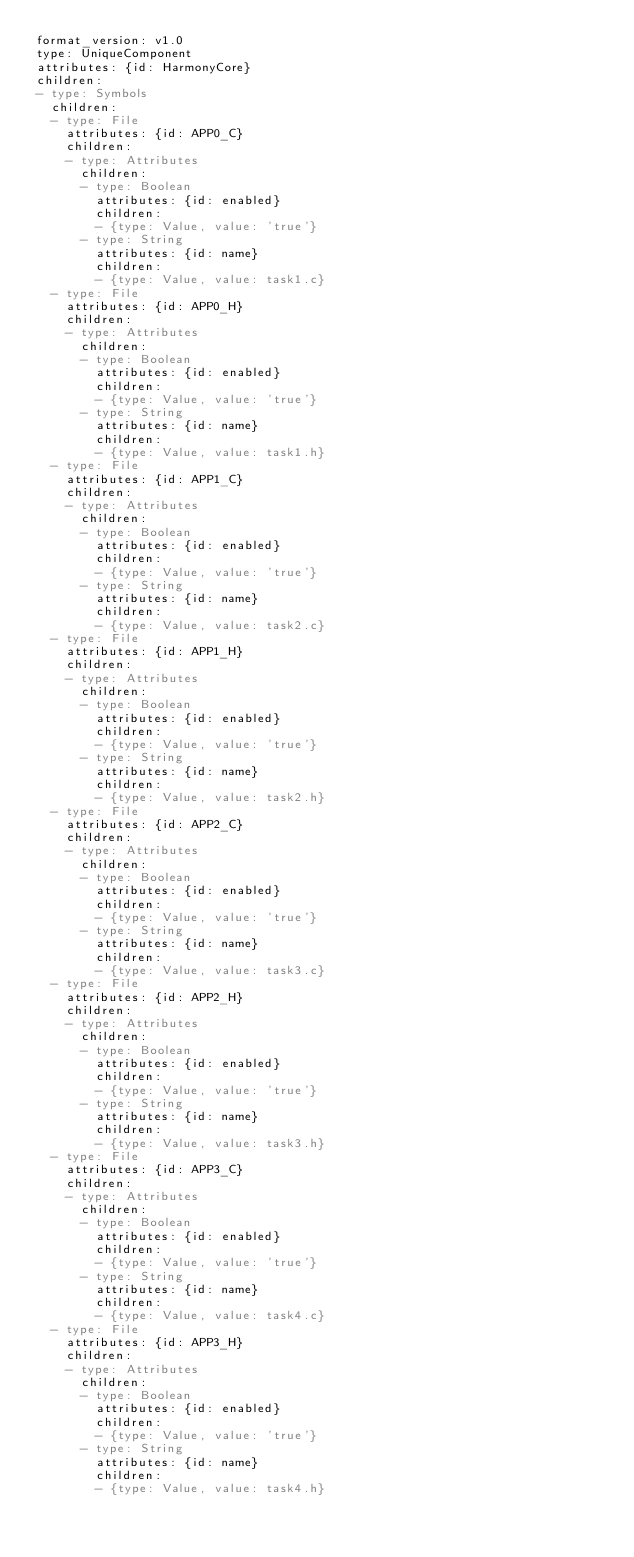<code> <loc_0><loc_0><loc_500><loc_500><_YAML_>format_version: v1.0
type: UniqueComponent
attributes: {id: HarmonyCore}
children:
- type: Symbols
  children:
  - type: File
    attributes: {id: APP0_C}
    children:
    - type: Attributes
      children:
      - type: Boolean
        attributes: {id: enabled}
        children:
        - {type: Value, value: 'true'}
      - type: String
        attributes: {id: name}
        children:
        - {type: Value, value: task1.c}
  - type: File
    attributes: {id: APP0_H}
    children:
    - type: Attributes
      children:
      - type: Boolean
        attributes: {id: enabled}
        children:
        - {type: Value, value: 'true'}
      - type: String
        attributes: {id: name}
        children:
        - {type: Value, value: task1.h}
  - type: File
    attributes: {id: APP1_C}
    children:
    - type: Attributes
      children:
      - type: Boolean
        attributes: {id: enabled}
        children:
        - {type: Value, value: 'true'}
      - type: String
        attributes: {id: name}
        children:
        - {type: Value, value: task2.c}
  - type: File
    attributes: {id: APP1_H}
    children:
    - type: Attributes
      children:
      - type: Boolean
        attributes: {id: enabled}
        children:
        - {type: Value, value: 'true'}
      - type: String
        attributes: {id: name}
        children:
        - {type: Value, value: task2.h}
  - type: File
    attributes: {id: APP2_C}
    children:
    - type: Attributes
      children:
      - type: Boolean
        attributes: {id: enabled}
        children:
        - {type: Value, value: 'true'}
      - type: String
        attributes: {id: name}
        children:
        - {type: Value, value: task3.c}
  - type: File
    attributes: {id: APP2_H}
    children:
    - type: Attributes
      children:
      - type: Boolean
        attributes: {id: enabled}
        children:
        - {type: Value, value: 'true'}
      - type: String
        attributes: {id: name}
        children:
        - {type: Value, value: task3.h}
  - type: File
    attributes: {id: APP3_C}
    children:
    - type: Attributes
      children:
      - type: Boolean
        attributes: {id: enabled}
        children:
        - {type: Value, value: 'true'}
      - type: String
        attributes: {id: name}
        children:
        - {type: Value, value: task4.c}
  - type: File
    attributes: {id: APP3_H}
    children:
    - type: Attributes
      children:
      - type: Boolean
        attributes: {id: enabled}
        children:
        - {type: Value, value: 'true'}
      - type: String
        attributes: {id: name}
        children:
        - {type: Value, value: task4.h}</code> 